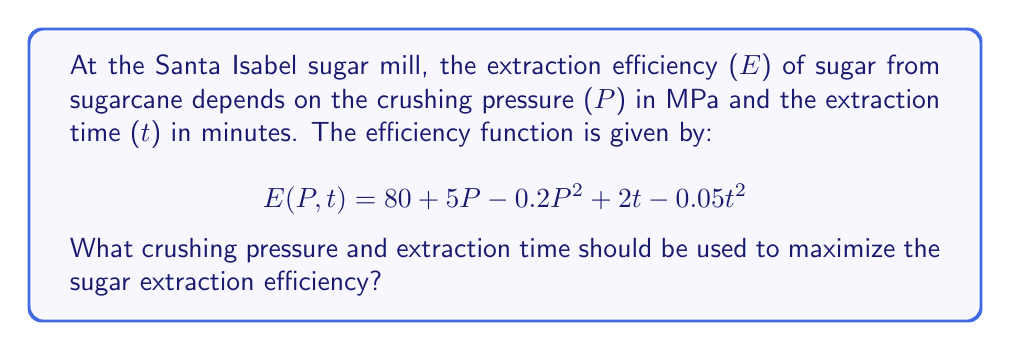Help me with this question. To find the maximum efficiency, we need to find the critical points of the function $E(P,t)$ by taking partial derivatives with respect to P and t and setting them equal to zero.

Step 1: Calculate partial derivatives
$$\frac{\partial E}{\partial P} = 5 - 0.4P$$
$$\frac{\partial E}{\partial t} = 2 - 0.1t$$

Step 2: Set partial derivatives to zero and solve
$$5 - 0.4P = 0$$
$$P = 12.5 \text{ MPa}$$

$$2 - 0.1t = 0$$
$$t = 20 \text{ minutes}$$

Step 3: Verify it's a maximum using the second derivative test
Calculate the second partial derivatives:
$$\frac{\partial^2 E}{\partial P^2} = -0.4$$
$$\frac{\partial^2 E}{\partial t^2} = -0.1$$
$$\frac{\partial^2 E}{\partial P \partial t} = 0$$

The Hessian matrix is:
$$H = \begin{bmatrix} 
-0.4 & 0 \\
0 & -0.1
\end{bmatrix}$$

Since $\frac{\partial^2 E}{\partial P^2} < 0$ and $\det(H) > 0$, the critical point is a local maximum.

Step 4: Calculate the maximum efficiency
$$E(12.5, 20) = 80 + 5(12.5) - 0.2(12.5)^2 + 2(20) - 0.05(20)^2$$
$$= 80 + 62.5 - 31.25 + 40 - 20 = 131.25$$

Therefore, the maximum efficiency is achieved at P = 12.5 MPa and t = 20 minutes, resulting in an efficiency of 131.25%.
Answer: P = 12.5 MPa, t = 20 minutes 